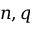<formula> <loc_0><loc_0><loc_500><loc_500>n , q</formula> 